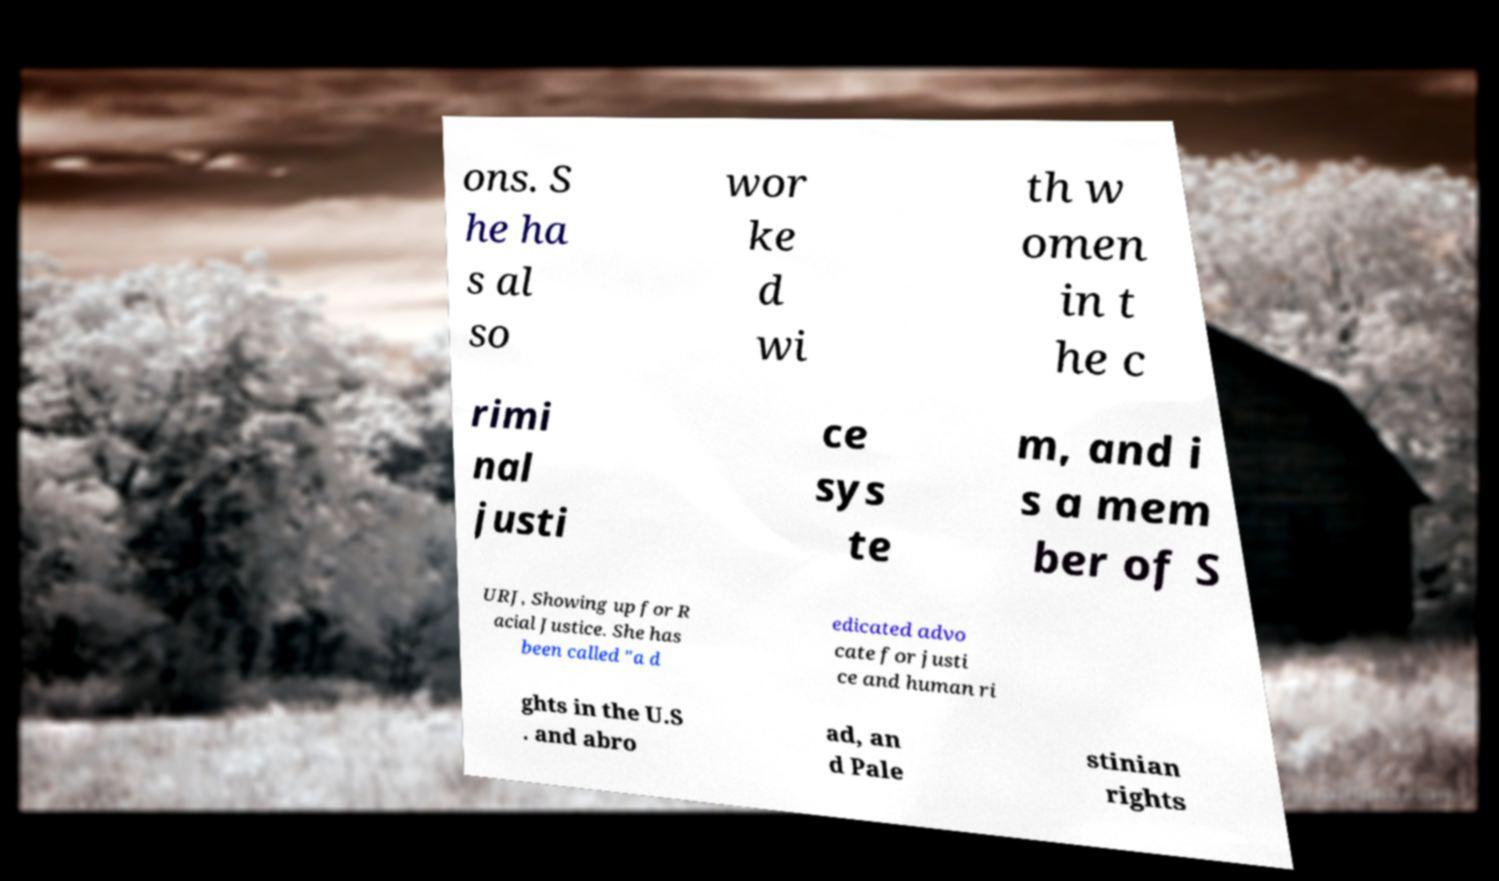Could you assist in decoding the text presented in this image and type it out clearly? ons. S he ha s al so wor ke d wi th w omen in t he c rimi nal justi ce sys te m, and i s a mem ber of S URJ, Showing up for R acial Justice. She has been called "a d edicated advo cate for justi ce and human ri ghts in the U.S . and abro ad, an d Pale stinian rights 